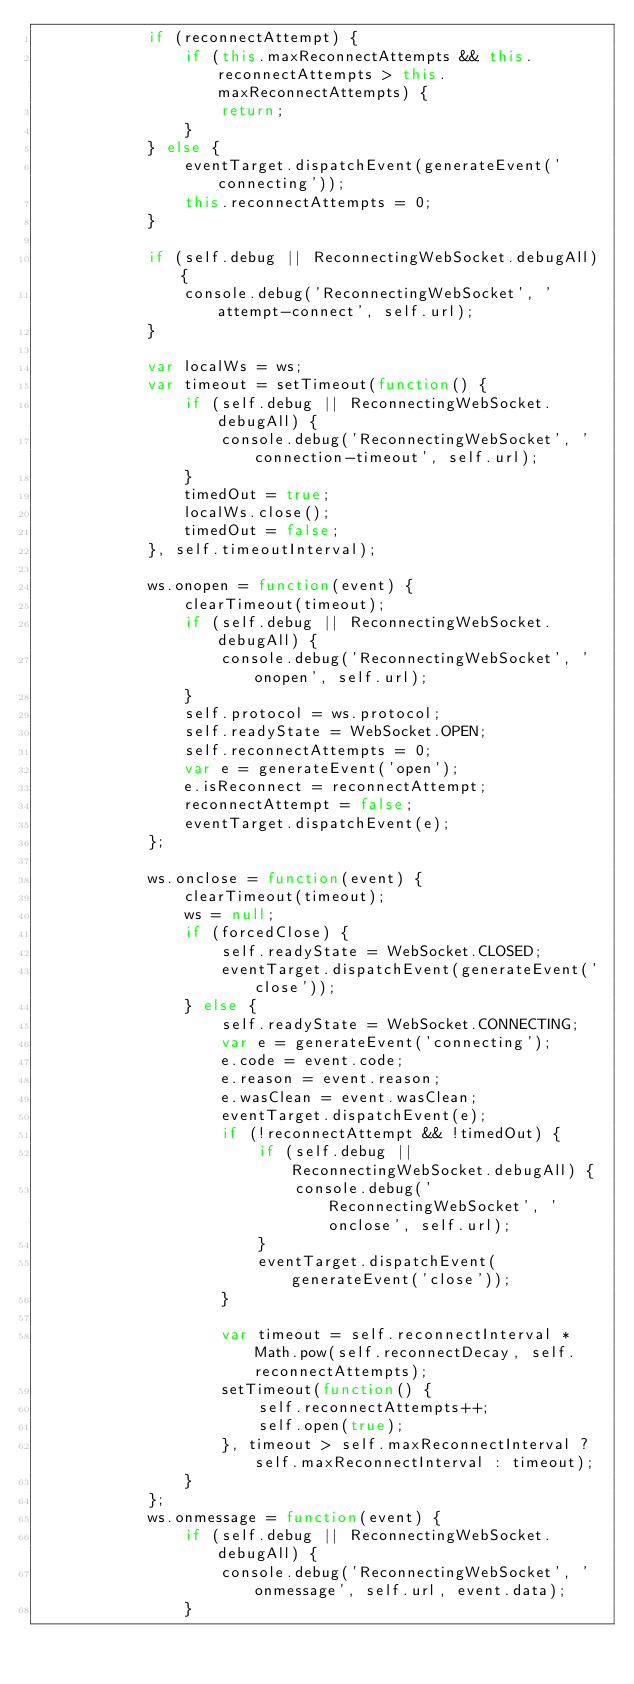Convert code to text. <code><loc_0><loc_0><loc_500><loc_500><_JavaScript_>            if (reconnectAttempt) {
                if (this.maxReconnectAttempts && this.reconnectAttempts > this.maxReconnectAttempts) {
                    return;
                }
            } else {
                eventTarget.dispatchEvent(generateEvent('connecting'));
                this.reconnectAttempts = 0;
            }

            if (self.debug || ReconnectingWebSocket.debugAll) {
                console.debug('ReconnectingWebSocket', 'attempt-connect', self.url);
            }

            var localWs = ws;
            var timeout = setTimeout(function() {
                if (self.debug || ReconnectingWebSocket.debugAll) {
                    console.debug('ReconnectingWebSocket', 'connection-timeout', self.url);
                }
                timedOut = true;
                localWs.close();
                timedOut = false;
            }, self.timeoutInterval);

            ws.onopen = function(event) {
                clearTimeout(timeout);
                if (self.debug || ReconnectingWebSocket.debugAll) {
                    console.debug('ReconnectingWebSocket', 'onopen', self.url);
                }
                self.protocol = ws.protocol;
                self.readyState = WebSocket.OPEN;
                self.reconnectAttempts = 0;
                var e = generateEvent('open');
                e.isReconnect = reconnectAttempt;
                reconnectAttempt = false;
                eventTarget.dispatchEvent(e);
            };

            ws.onclose = function(event) {
                clearTimeout(timeout);
                ws = null;
                if (forcedClose) {
                    self.readyState = WebSocket.CLOSED;
                    eventTarget.dispatchEvent(generateEvent('close'));
                } else {
                    self.readyState = WebSocket.CONNECTING;
                    var e = generateEvent('connecting');
                    e.code = event.code;
                    e.reason = event.reason;
                    e.wasClean = event.wasClean;
                    eventTarget.dispatchEvent(e);
                    if (!reconnectAttempt && !timedOut) {
                        if (self.debug || ReconnectingWebSocket.debugAll) {
                            console.debug('ReconnectingWebSocket', 'onclose', self.url);
                        }
                        eventTarget.dispatchEvent(generateEvent('close'));
                    }

                    var timeout = self.reconnectInterval * Math.pow(self.reconnectDecay, self.reconnectAttempts);
                    setTimeout(function() {
                        self.reconnectAttempts++;
                        self.open(true);
                    }, timeout > self.maxReconnectInterval ? self.maxReconnectInterval : timeout);
                }
            };
            ws.onmessage = function(event) {
                if (self.debug || ReconnectingWebSocket.debugAll) {
                    console.debug('ReconnectingWebSocket', 'onmessage', self.url, event.data);
                }</code> 